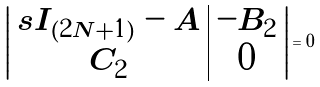<formula> <loc_0><loc_0><loc_500><loc_500>\left | \begin{array} { c | c } s I _ { ( 2 N + 1 ) } - A & - B _ { 2 } \\ C _ { 2 } & 0 \end{array} \right | = 0</formula> 